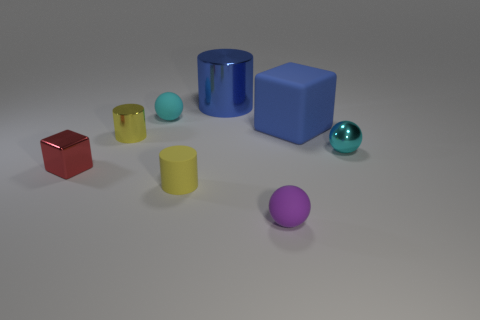Subtract all cyan cylinders. How many cyan spheres are left? 2 Subtract all metallic cylinders. How many cylinders are left? 1 Subtract 1 balls. How many balls are left? 2 Add 1 big red metal cylinders. How many objects exist? 9 Subtract all cylinders. How many objects are left? 5 Add 1 yellow cylinders. How many yellow cylinders are left? 3 Add 1 tiny red things. How many tiny red things exist? 2 Subtract 0 cyan blocks. How many objects are left? 8 Subtract all tiny yellow matte cylinders. Subtract all big blue cylinders. How many objects are left? 6 